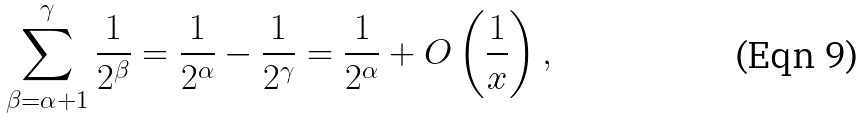Convert formula to latex. <formula><loc_0><loc_0><loc_500><loc_500>\sum _ { \beta = \alpha + 1 } ^ { \gamma } \frac { 1 } { 2 ^ { \beta } } = \frac { 1 } { 2 ^ { \alpha } } - \frac { 1 } { 2 ^ { \gamma } } = \frac { 1 } { 2 ^ { \alpha } } + O \left ( \frac { 1 } { x } \right ) ,</formula> 